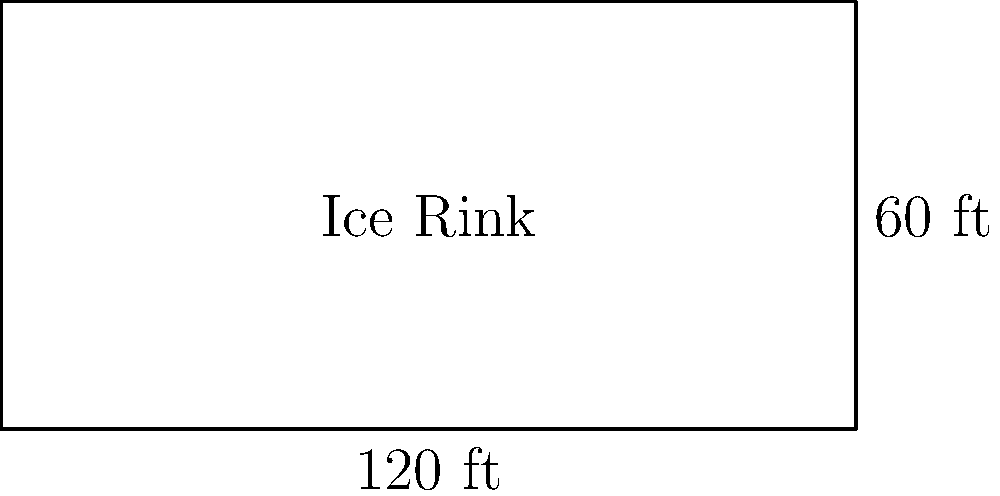The City of Saint Paul is planning to construct a rectangular ice rink for winter activities. The rink's length is twice its width, and its total perimeter is 360 feet. If the ice surface needs to be 4 inches thick, what is the volume of water needed to create the ice, in cubic feet? Let's approach this step-by-step:

1) Let the width of the rink be $x$ feet and the length be $2x$ feet.

2) Given that the perimeter is 360 feet, we can set up the equation:
   $2x + 2(2x) = 360$
   $2x + 4x = 360$
   $6x = 360$

3) Solving for $x$:
   $x = 360 / 6 = 60$

4) So the width is 60 feet and the length is 120 feet.

5) The area of the rink is:
   $A = 60 \times 120 = 7,200$ square feet

6) The thickness of the ice is 4 inches, which is $4/12 = 1/3$ foot.

7) The volume of water needed is:
   $V = 7,200 \times 1/3 = 2,400$ cubic feet

Therefore, 2,400 cubic feet of water is needed to create the ice surface.
Answer: 2,400 cubic feet 